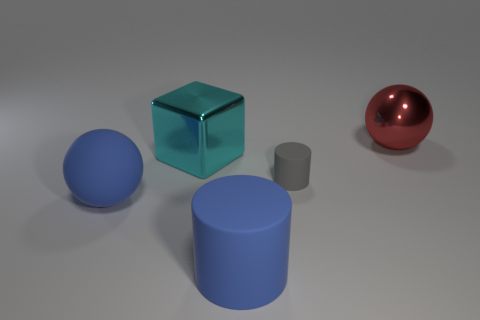Add 2 gray matte cylinders. How many objects exist? 7 Subtract all spheres. How many objects are left? 3 Add 1 large blue matte balls. How many large blue matte balls are left? 2 Add 1 large blue cylinders. How many large blue cylinders exist? 2 Subtract 0 gray spheres. How many objects are left? 5 Subtract all rubber spheres. Subtract all tiny gray matte cylinders. How many objects are left? 3 